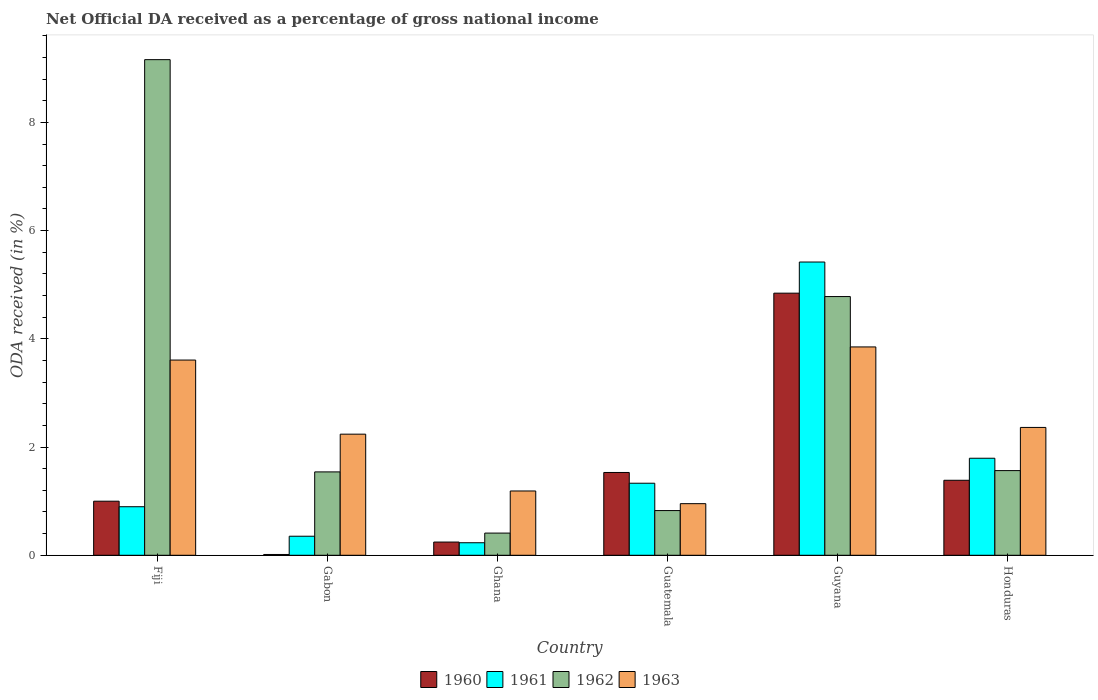How many different coloured bars are there?
Make the answer very short. 4. Are the number of bars per tick equal to the number of legend labels?
Keep it short and to the point. Yes. Are the number of bars on each tick of the X-axis equal?
Provide a short and direct response. Yes. How many bars are there on the 4th tick from the left?
Provide a short and direct response. 4. What is the label of the 4th group of bars from the left?
Ensure brevity in your answer.  Guatemala. What is the net official DA received in 1962 in Guyana?
Offer a very short reply. 4.78. Across all countries, what is the maximum net official DA received in 1960?
Your response must be concise. 4.84. Across all countries, what is the minimum net official DA received in 1963?
Provide a short and direct response. 0.95. In which country was the net official DA received in 1963 maximum?
Your response must be concise. Guyana. In which country was the net official DA received in 1962 minimum?
Offer a very short reply. Ghana. What is the total net official DA received in 1963 in the graph?
Your answer should be compact. 14.2. What is the difference between the net official DA received in 1963 in Fiji and that in Guyana?
Your answer should be compact. -0.24. What is the difference between the net official DA received in 1961 in Guyana and the net official DA received in 1962 in Ghana?
Offer a very short reply. 5.01. What is the average net official DA received in 1961 per country?
Give a very brief answer. 1.67. What is the difference between the net official DA received of/in 1962 and net official DA received of/in 1963 in Guatemala?
Give a very brief answer. -0.13. What is the ratio of the net official DA received in 1961 in Gabon to that in Guatemala?
Offer a terse response. 0.26. What is the difference between the highest and the second highest net official DA received in 1961?
Your answer should be compact. -3.63. What is the difference between the highest and the lowest net official DA received in 1963?
Keep it short and to the point. 2.9. Is it the case that in every country, the sum of the net official DA received in 1962 and net official DA received in 1961 is greater than the sum of net official DA received in 1963 and net official DA received in 1960?
Ensure brevity in your answer.  No. Is it the case that in every country, the sum of the net official DA received in 1962 and net official DA received in 1961 is greater than the net official DA received in 1960?
Keep it short and to the point. Yes. How many bars are there?
Your answer should be very brief. 24. Are all the bars in the graph horizontal?
Provide a short and direct response. No. How many countries are there in the graph?
Your answer should be very brief. 6. Does the graph contain any zero values?
Provide a succinct answer. No. Does the graph contain grids?
Give a very brief answer. No. How many legend labels are there?
Provide a succinct answer. 4. What is the title of the graph?
Your response must be concise. Net Official DA received as a percentage of gross national income. Does "2013" appear as one of the legend labels in the graph?
Your answer should be very brief. No. What is the label or title of the X-axis?
Keep it short and to the point. Country. What is the label or title of the Y-axis?
Give a very brief answer. ODA received (in %). What is the ODA received (in %) of 1960 in Fiji?
Your answer should be very brief. 1. What is the ODA received (in %) in 1961 in Fiji?
Offer a terse response. 0.9. What is the ODA received (in %) of 1962 in Fiji?
Make the answer very short. 9.16. What is the ODA received (in %) in 1963 in Fiji?
Ensure brevity in your answer.  3.61. What is the ODA received (in %) in 1960 in Gabon?
Provide a short and direct response. 0.01. What is the ODA received (in %) of 1961 in Gabon?
Your answer should be very brief. 0.35. What is the ODA received (in %) of 1962 in Gabon?
Your answer should be very brief. 1.54. What is the ODA received (in %) in 1963 in Gabon?
Give a very brief answer. 2.24. What is the ODA received (in %) of 1960 in Ghana?
Your response must be concise. 0.24. What is the ODA received (in %) of 1961 in Ghana?
Your response must be concise. 0.23. What is the ODA received (in %) of 1962 in Ghana?
Provide a short and direct response. 0.41. What is the ODA received (in %) of 1963 in Ghana?
Offer a terse response. 1.19. What is the ODA received (in %) in 1960 in Guatemala?
Ensure brevity in your answer.  1.53. What is the ODA received (in %) in 1961 in Guatemala?
Make the answer very short. 1.33. What is the ODA received (in %) of 1962 in Guatemala?
Offer a terse response. 0.83. What is the ODA received (in %) in 1963 in Guatemala?
Give a very brief answer. 0.95. What is the ODA received (in %) of 1960 in Guyana?
Offer a terse response. 4.84. What is the ODA received (in %) in 1961 in Guyana?
Your answer should be very brief. 5.42. What is the ODA received (in %) in 1962 in Guyana?
Make the answer very short. 4.78. What is the ODA received (in %) in 1963 in Guyana?
Make the answer very short. 3.85. What is the ODA received (in %) of 1960 in Honduras?
Your answer should be compact. 1.39. What is the ODA received (in %) of 1961 in Honduras?
Your answer should be very brief. 1.79. What is the ODA received (in %) in 1962 in Honduras?
Keep it short and to the point. 1.56. What is the ODA received (in %) of 1963 in Honduras?
Offer a terse response. 2.36. Across all countries, what is the maximum ODA received (in %) of 1960?
Provide a succinct answer. 4.84. Across all countries, what is the maximum ODA received (in %) in 1961?
Give a very brief answer. 5.42. Across all countries, what is the maximum ODA received (in %) in 1962?
Offer a very short reply. 9.16. Across all countries, what is the maximum ODA received (in %) in 1963?
Provide a succinct answer. 3.85. Across all countries, what is the minimum ODA received (in %) in 1960?
Give a very brief answer. 0.01. Across all countries, what is the minimum ODA received (in %) in 1961?
Provide a succinct answer. 0.23. Across all countries, what is the minimum ODA received (in %) in 1962?
Keep it short and to the point. 0.41. Across all countries, what is the minimum ODA received (in %) in 1963?
Keep it short and to the point. 0.95. What is the total ODA received (in %) in 1960 in the graph?
Provide a succinct answer. 9.02. What is the total ODA received (in %) in 1961 in the graph?
Ensure brevity in your answer.  10.03. What is the total ODA received (in %) in 1962 in the graph?
Make the answer very short. 18.28. What is the total ODA received (in %) in 1963 in the graph?
Keep it short and to the point. 14.2. What is the difference between the ODA received (in %) of 1960 in Fiji and that in Gabon?
Your answer should be very brief. 0.98. What is the difference between the ODA received (in %) of 1961 in Fiji and that in Gabon?
Provide a succinct answer. 0.55. What is the difference between the ODA received (in %) of 1962 in Fiji and that in Gabon?
Your answer should be very brief. 7.62. What is the difference between the ODA received (in %) of 1963 in Fiji and that in Gabon?
Make the answer very short. 1.37. What is the difference between the ODA received (in %) in 1960 in Fiji and that in Ghana?
Keep it short and to the point. 0.76. What is the difference between the ODA received (in %) in 1961 in Fiji and that in Ghana?
Make the answer very short. 0.67. What is the difference between the ODA received (in %) of 1962 in Fiji and that in Ghana?
Give a very brief answer. 8.75. What is the difference between the ODA received (in %) in 1963 in Fiji and that in Ghana?
Your answer should be compact. 2.42. What is the difference between the ODA received (in %) in 1960 in Fiji and that in Guatemala?
Ensure brevity in your answer.  -0.53. What is the difference between the ODA received (in %) in 1961 in Fiji and that in Guatemala?
Give a very brief answer. -0.43. What is the difference between the ODA received (in %) in 1962 in Fiji and that in Guatemala?
Your answer should be compact. 8.33. What is the difference between the ODA received (in %) in 1963 in Fiji and that in Guatemala?
Provide a short and direct response. 2.65. What is the difference between the ODA received (in %) of 1960 in Fiji and that in Guyana?
Your answer should be compact. -3.84. What is the difference between the ODA received (in %) in 1961 in Fiji and that in Guyana?
Make the answer very short. -4.52. What is the difference between the ODA received (in %) of 1962 in Fiji and that in Guyana?
Ensure brevity in your answer.  4.38. What is the difference between the ODA received (in %) of 1963 in Fiji and that in Guyana?
Offer a terse response. -0.24. What is the difference between the ODA received (in %) in 1960 in Fiji and that in Honduras?
Your response must be concise. -0.39. What is the difference between the ODA received (in %) of 1961 in Fiji and that in Honduras?
Keep it short and to the point. -0.9. What is the difference between the ODA received (in %) of 1962 in Fiji and that in Honduras?
Ensure brevity in your answer.  7.59. What is the difference between the ODA received (in %) of 1963 in Fiji and that in Honduras?
Ensure brevity in your answer.  1.25. What is the difference between the ODA received (in %) of 1960 in Gabon and that in Ghana?
Keep it short and to the point. -0.23. What is the difference between the ODA received (in %) of 1961 in Gabon and that in Ghana?
Provide a succinct answer. 0.12. What is the difference between the ODA received (in %) in 1962 in Gabon and that in Ghana?
Make the answer very short. 1.13. What is the difference between the ODA received (in %) in 1963 in Gabon and that in Ghana?
Make the answer very short. 1.05. What is the difference between the ODA received (in %) in 1960 in Gabon and that in Guatemala?
Offer a very short reply. -1.52. What is the difference between the ODA received (in %) of 1961 in Gabon and that in Guatemala?
Offer a terse response. -0.98. What is the difference between the ODA received (in %) of 1962 in Gabon and that in Guatemala?
Your answer should be compact. 0.71. What is the difference between the ODA received (in %) of 1963 in Gabon and that in Guatemala?
Your response must be concise. 1.28. What is the difference between the ODA received (in %) of 1960 in Gabon and that in Guyana?
Your response must be concise. -4.83. What is the difference between the ODA received (in %) in 1961 in Gabon and that in Guyana?
Make the answer very short. -5.07. What is the difference between the ODA received (in %) in 1962 in Gabon and that in Guyana?
Offer a very short reply. -3.24. What is the difference between the ODA received (in %) of 1963 in Gabon and that in Guyana?
Provide a succinct answer. -1.61. What is the difference between the ODA received (in %) of 1960 in Gabon and that in Honduras?
Offer a very short reply. -1.37. What is the difference between the ODA received (in %) in 1961 in Gabon and that in Honduras?
Your answer should be compact. -1.44. What is the difference between the ODA received (in %) in 1962 in Gabon and that in Honduras?
Offer a very short reply. -0.02. What is the difference between the ODA received (in %) in 1963 in Gabon and that in Honduras?
Keep it short and to the point. -0.12. What is the difference between the ODA received (in %) of 1960 in Ghana and that in Guatemala?
Offer a terse response. -1.29. What is the difference between the ODA received (in %) in 1961 in Ghana and that in Guatemala?
Your answer should be very brief. -1.1. What is the difference between the ODA received (in %) in 1962 in Ghana and that in Guatemala?
Keep it short and to the point. -0.42. What is the difference between the ODA received (in %) of 1963 in Ghana and that in Guatemala?
Make the answer very short. 0.23. What is the difference between the ODA received (in %) of 1960 in Ghana and that in Guyana?
Your response must be concise. -4.6. What is the difference between the ODA received (in %) in 1961 in Ghana and that in Guyana?
Offer a very short reply. -5.19. What is the difference between the ODA received (in %) in 1962 in Ghana and that in Guyana?
Provide a succinct answer. -4.37. What is the difference between the ODA received (in %) in 1963 in Ghana and that in Guyana?
Your answer should be compact. -2.66. What is the difference between the ODA received (in %) in 1960 in Ghana and that in Honduras?
Offer a very short reply. -1.14. What is the difference between the ODA received (in %) of 1961 in Ghana and that in Honduras?
Give a very brief answer. -1.56. What is the difference between the ODA received (in %) of 1962 in Ghana and that in Honduras?
Offer a very short reply. -1.15. What is the difference between the ODA received (in %) in 1963 in Ghana and that in Honduras?
Provide a succinct answer. -1.17. What is the difference between the ODA received (in %) in 1960 in Guatemala and that in Guyana?
Provide a short and direct response. -3.31. What is the difference between the ODA received (in %) in 1961 in Guatemala and that in Guyana?
Keep it short and to the point. -4.09. What is the difference between the ODA received (in %) of 1962 in Guatemala and that in Guyana?
Offer a terse response. -3.96. What is the difference between the ODA received (in %) in 1963 in Guatemala and that in Guyana?
Make the answer very short. -2.9. What is the difference between the ODA received (in %) of 1960 in Guatemala and that in Honduras?
Your answer should be very brief. 0.14. What is the difference between the ODA received (in %) of 1961 in Guatemala and that in Honduras?
Provide a short and direct response. -0.46. What is the difference between the ODA received (in %) in 1962 in Guatemala and that in Honduras?
Offer a terse response. -0.74. What is the difference between the ODA received (in %) of 1963 in Guatemala and that in Honduras?
Your answer should be compact. -1.41. What is the difference between the ODA received (in %) of 1960 in Guyana and that in Honduras?
Ensure brevity in your answer.  3.46. What is the difference between the ODA received (in %) in 1961 in Guyana and that in Honduras?
Offer a very short reply. 3.63. What is the difference between the ODA received (in %) of 1962 in Guyana and that in Honduras?
Make the answer very short. 3.22. What is the difference between the ODA received (in %) in 1963 in Guyana and that in Honduras?
Provide a short and direct response. 1.49. What is the difference between the ODA received (in %) in 1960 in Fiji and the ODA received (in %) in 1961 in Gabon?
Provide a short and direct response. 0.65. What is the difference between the ODA received (in %) of 1960 in Fiji and the ODA received (in %) of 1962 in Gabon?
Ensure brevity in your answer.  -0.54. What is the difference between the ODA received (in %) in 1960 in Fiji and the ODA received (in %) in 1963 in Gabon?
Your answer should be compact. -1.24. What is the difference between the ODA received (in %) in 1961 in Fiji and the ODA received (in %) in 1962 in Gabon?
Provide a succinct answer. -0.64. What is the difference between the ODA received (in %) of 1961 in Fiji and the ODA received (in %) of 1963 in Gabon?
Ensure brevity in your answer.  -1.34. What is the difference between the ODA received (in %) in 1962 in Fiji and the ODA received (in %) in 1963 in Gabon?
Offer a very short reply. 6.92. What is the difference between the ODA received (in %) in 1960 in Fiji and the ODA received (in %) in 1961 in Ghana?
Provide a short and direct response. 0.77. What is the difference between the ODA received (in %) in 1960 in Fiji and the ODA received (in %) in 1962 in Ghana?
Your answer should be compact. 0.59. What is the difference between the ODA received (in %) of 1960 in Fiji and the ODA received (in %) of 1963 in Ghana?
Keep it short and to the point. -0.19. What is the difference between the ODA received (in %) of 1961 in Fiji and the ODA received (in %) of 1962 in Ghana?
Make the answer very short. 0.49. What is the difference between the ODA received (in %) of 1961 in Fiji and the ODA received (in %) of 1963 in Ghana?
Give a very brief answer. -0.29. What is the difference between the ODA received (in %) in 1962 in Fiji and the ODA received (in %) in 1963 in Ghana?
Your response must be concise. 7.97. What is the difference between the ODA received (in %) in 1960 in Fiji and the ODA received (in %) in 1961 in Guatemala?
Your answer should be very brief. -0.33. What is the difference between the ODA received (in %) in 1960 in Fiji and the ODA received (in %) in 1962 in Guatemala?
Your answer should be compact. 0.17. What is the difference between the ODA received (in %) in 1960 in Fiji and the ODA received (in %) in 1963 in Guatemala?
Keep it short and to the point. 0.05. What is the difference between the ODA received (in %) in 1961 in Fiji and the ODA received (in %) in 1962 in Guatemala?
Provide a short and direct response. 0.07. What is the difference between the ODA received (in %) of 1961 in Fiji and the ODA received (in %) of 1963 in Guatemala?
Offer a very short reply. -0.06. What is the difference between the ODA received (in %) of 1962 in Fiji and the ODA received (in %) of 1963 in Guatemala?
Your answer should be very brief. 8.21. What is the difference between the ODA received (in %) in 1960 in Fiji and the ODA received (in %) in 1961 in Guyana?
Offer a very short reply. -4.42. What is the difference between the ODA received (in %) of 1960 in Fiji and the ODA received (in %) of 1962 in Guyana?
Make the answer very short. -3.78. What is the difference between the ODA received (in %) of 1960 in Fiji and the ODA received (in %) of 1963 in Guyana?
Your answer should be compact. -2.85. What is the difference between the ODA received (in %) in 1961 in Fiji and the ODA received (in %) in 1962 in Guyana?
Make the answer very short. -3.88. What is the difference between the ODA received (in %) in 1961 in Fiji and the ODA received (in %) in 1963 in Guyana?
Offer a very short reply. -2.95. What is the difference between the ODA received (in %) of 1962 in Fiji and the ODA received (in %) of 1963 in Guyana?
Your answer should be very brief. 5.31. What is the difference between the ODA received (in %) of 1960 in Fiji and the ODA received (in %) of 1961 in Honduras?
Keep it short and to the point. -0.79. What is the difference between the ODA received (in %) in 1960 in Fiji and the ODA received (in %) in 1962 in Honduras?
Keep it short and to the point. -0.57. What is the difference between the ODA received (in %) in 1960 in Fiji and the ODA received (in %) in 1963 in Honduras?
Make the answer very short. -1.36. What is the difference between the ODA received (in %) of 1961 in Fiji and the ODA received (in %) of 1962 in Honduras?
Offer a very short reply. -0.67. What is the difference between the ODA received (in %) in 1961 in Fiji and the ODA received (in %) in 1963 in Honduras?
Your response must be concise. -1.47. What is the difference between the ODA received (in %) of 1962 in Fiji and the ODA received (in %) of 1963 in Honduras?
Keep it short and to the point. 6.8. What is the difference between the ODA received (in %) in 1960 in Gabon and the ODA received (in %) in 1961 in Ghana?
Your answer should be compact. -0.22. What is the difference between the ODA received (in %) in 1960 in Gabon and the ODA received (in %) in 1962 in Ghana?
Your response must be concise. -0.4. What is the difference between the ODA received (in %) in 1960 in Gabon and the ODA received (in %) in 1963 in Ghana?
Your answer should be compact. -1.17. What is the difference between the ODA received (in %) of 1961 in Gabon and the ODA received (in %) of 1962 in Ghana?
Keep it short and to the point. -0.06. What is the difference between the ODA received (in %) in 1961 in Gabon and the ODA received (in %) in 1963 in Ghana?
Make the answer very short. -0.84. What is the difference between the ODA received (in %) of 1962 in Gabon and the ODA received (in %) of 1963 in Ghana?
Keep it short and to the point. 0.35. What is the difference between the ODA received (in %) of 1960 in Gabon and the ODA received (in %) of 1961 in Guatemala?
Provide a succinct answer. -1.32. What is the difference between the ODA received (in %) of 1960 in Gabon and the ODA received (in %) of 1962 in Guatemala?
Keep it short and to the point. -0.81. What is the difference between the ODA received (in %) in 1960 in Gabon and the ODA received (in %) in 1963 in Guatemala?
Offer a very short reply. -0.94. What is the difference between the ODA received (in %) of 1961 in Gabon and the ODA received (in %) of 1962 in Guatemala?
Give a very brief answer. -0.47. What is the difference between the ODA received (in %) of 1961 in Gabon and the ODA received (in %) of 1963 in Guatemala?
Your response must be concise. -0.6. What is the difference between the ODA received (in %) of 1962 in Gabon and the ODA received (in %) of 1963 in Guatemala?
Your answer should be very brief. 0.59. What is the difference between the ODA received (in %) in 1960 in Gabon and the ODA received (in %) in 1961 in Guyana?
Provide a succinct answer. -5.4. What is the difference between the ODA received (in %) in 1960 in Gabon and the ODA received (in %) in 1962 in Guyana?
Offer a very short reply. -4.77. What is the difference between the ODA received (in %) of 1960 in Gabon and the ODA received (in %) of 1963 in Guyana?
Keep it short and to the point. -3.84. What is the difference between the ODA received (in %) of 1961 in Gabon and the ODA received (in %) of 1962 in Guyana?
Provide a succinct answer. -4.43. What is the difference between the ODA received (in %) in 1961 in Gabon and the ODA received (in %) in 1963 in Guyana?
Keep it short and to the point. -3.5. What is the difference between the ODA received (in %) in 1962 in Gabon and the ODA received (in %) in 1963 in Guyana?
Keep it short and to the point. -2.31. What is the difference between the ODA received (in %) of 1960 in Gabon and the ODA received (in %) of 1961 in Honduras?
Offer a very short reply. -1.78. What is the difference between the ODA received (in %) in 1960 in Gabon and the ODA received (in %) in 1962 in Honduras?
Ensure brevity in your answer.  -1.55. What is the difference between the ODA received (in %) in 1960 in Gabon and the ODA received (in %) in 1963 in Honduras?
Give a very brief answer. -2.35. What is the difference between the ODA received (in %) in 1961 in Gabon and the ODA received (in %) in 1962 in Honduras?
Your answer should be very brief. -1.21. What is the difference between the ODA received (in %) of 1961 in Gabon and the ODA received (in %) of 1963 in Honduras?
Your answer should be compact. -2.01. What is the difference between the ODA received (in %) in 1962 in Gabon and the ODA received (in %) in 1963 in Honduras?
Provide a short and direct response. -0.82. What is the difference between the ODA received (in %) of 1960 in Ghana and the ODA received (in %) of 1961 in Guatemala?
Keep it short and to the point. -1.09. What is the difference between the ODA received (in %) of 1960 in Ghana and the ODA received (in %) of 1962 in Guatemala?
Offer a very short reply. -0.58. What is the difference between the ODA received (in %) of 1960 in Ghana and the ODA received (in %) of 1963 in Guatemala?
Provide a short and direct response. -0.71. What is the difference between the ODA received (in %) of 1961 in Ghana and the ODA received (in %) of 1962 in Guatemala?
Your answer should be very brief. -0.59. What is the difference between the ODA received (in %) in 1961 in Ghana and the ODA received (in %) in 1963 in Guatemala?
Make the answer very short. -0.72. What is the difference between the ODA received (in %) of 1962 in Ghana and the ODA received (in %) of 1963 in Guatemala?
Provide a short and direct response. -0.54. What is the difference between the ODA received (in %) in 1960 in Ghana and the ODA received (in %) in 1961 in Guyana?
Provide a short and direct response. -5.18. What is the difference between the ODA received (in %) in 1960 in Ghana and the ODA received (in %) in 1962 in Guyana?
Your response must be concise. -4.54. What is the difference between the ODA received (in %) of 1960 in Ghana and the ODA received (in %) of 1963 in Guyana?
Provide a short and direct response. -3.61. What is the difference between the ODA received (in %) of 1961 in Ghana and the ODA received (in %) of 1962 in Guyana?
Your answer should be compact. -4.55. What is the difference between the ODA received (in %) in 1961 in Ghana and the ODA received (in %) in 1963 in Guyana?
Offer a terse response. -3.62. What is the difference between the ODA received (in %) in 1962 in Ghana and the ODA received (in %) in 1963 in Guyana?
Offer a terse response. -3.44. What is the difference between the ODA received (in %) in 1960 in Ghana and the ODA received (in %) in 1961 in Honduras?
Make the answer very short. -1.55. What is the difference between the ODA received (in %) in 1960 in Ghana and the ODA received (in %) in 1962 in Honduras?
Keep it short and to the point. -1.32. What is the difference between the ODA received (in %) of 1960 in Ghana and the ODA received (in %) of 1963 in Honduras?
Give a very brief answer. -2.12. What is the difference between the ODA received (in %) in 1961 in Ghana and the ODA received (in %) in 1962 in Honduras?
Your answer should be very brief. -1.33. What is the difference between the ODA received (in %) in 1961 in Ghana and the ODA received (in %) in 1963 in Honduras?
Your answer should be compact. -2.13. What is the difference between the ODA received (in %) of 1962 in Ghana and the ODA received (in %) of 1963 in Honduras?
Keep it short and to the point. -1.95. What is the difference between the ODA received (in %) in 1960 in Guatemala and the ODA received (in %) in 1961 in Guyana?
Provide a succinct answer. -3.89. What is the difference between the ODA received (in %) of 1960 in Guatemala and the ODA received (in %) of 1962 in Guyana?
Your answer should be compact. -3.25. What is the difference between the ODA received (in %) of 1960 in Guatemala and the ODA received (in %) of 1963 in Guyana?
Offer a terse response. -2.32. What is the difference between the ODA received (in %) in 1961 in Guatemala and the ODA received (in %) in 1962 in Guyana?
Ensure brevity in your answer.  -3.45. What is the difference between the ODA received (in %) in 1961 in Guatemala and the ODA received (in %) in 1963 in Guyana?
Your answer should be very brief. -2.52. What is the difference between the ODA received (in %) in 1962 in Guatemala and the ODA received (in %) in 1963 in Guyana?
Provide a succinct answer. -3.02. What is the difference between the ODA received (in %) of 1960 in Guatemala and the ODA received (in %) of 1961 in Honduras?
Ensure brevity in your answer.  -0.26. What is the difference between the ODA received (in %) in 1960 in Guatemala and the ODA received (in %) in 1962 in Honduras?
Ensure brevity in your answer.  -0.03. What is the difference between the ODA received (in %) in 1960 in Guatemala and the ODA received (in %) in 1963 in Honduras?
Give a very brief answer. -0.83. What is the difference between the ODA received (in %) of 1961 in Guatemala and the ODA received (in %) of 1962 in Honduras?
Your answer should be very brief. -0.23. What is the difference between the ODA received (in %) in 1961 in Guatemala and the ODA received (in %) in 1963 in Honduras?
Offer a very short reply. -1.03. What is the difference between the ODA received (in %) in 1962 in Guatemala and the ODA received (in %) in 1963 in Honduras?
Provide a short and direct response. -1.54. What is the difference between the ODA received (in %) of 1960 in Guyana and the ODA received (in %) of 1961 in Honduras?
Make the answer very short. 3.05. What is the difference between the ODA received (in %) of 1960 in Guyana and the ODA received (in %) of 1962 in Honduras?
Provide a succinct answer. 3.28. What is the difference between the ODA received (in %) of 1960 in Guyana and the ODA received (in %) of 1963 in Honduras?
Offer a very short reply. 2.48. What is the difference between the ODA received (in %) of 1961 in Guyana and the ODA received (in %) of 1962 in Honduras?
Provide a succinct answer. 3.85. What is the difference between the ODA received (in %) of 1961 in Guyana and the ODA received (in %) of 1963 in Honduras?
Offer a very short reply. 3.06. What is the difference between the ODA received (in %) in 1962 in Guyana and the ODA received (in %) in 1963 in Honduras?
Keep it short and to the point. 2.42. What is the average ODA received (in %) in 1960 per country?
Keep it short and to the point. 1.5. What is the average ODA received (in %) in 1961 per country?
Offer a very short reply. 1.67. What is the average ODA received (in %) of 1962 per country?
Make the answer very short. 3.05. What is the average ODA received (in %) in 1963 per country?
Your answer should be compact. 2.37. What is the difference between the ODA received (in %) of 1960 and ODA received (in %) of 1961 in Fiji?
Your answer should be compact. 0.1. What is the difference between the ODA received (in %) of 1960 and ODA received (in %) of 1962 in Fiji?
Make the answer very short. -8.16. What is the difference between the ODA received (in %) of 1960 and ODA received (in %) of 1963 in Fiji?
Provide a short and direct response. -2.61. What is the difference between the ODA received (in %) in 1961 and ODA received (in %) in 1962 in Fiji?
Your answer should be compact. -8.26. What is the difference between the ODA received (in %) of 1961 and ODA received (in %) of 1963 in Fiji?
Make the answer very short. -2.71. What is the difference between the ODA received (in %) in 1962 and ODA received (in %) in 1963 in Fiji?
Your answer should be compact. 5.55. What is the difference between the ODA received (in %) of 1960 and ODA received (in %) of 1961 in Gabon?
Your response must be concise. -0.34. What is the difference between the ODA received (in %) of 1960 and ODA received (in %) of 1962 in Gabon?
Make the answer very short. -1.53. What is the difference between the ODA received (in %) of 1960 and ODA received (in %) of 1963 in Gabon?
Make the answer very short. -2.22. What is the difference between the ODA received (in %) in 1961 and ODA received (in %) in 1962 in Gabon?
Your response must be concise. -1.19. What is the difference between the ODA received (in %) of 1961 and ODA received (in %) of 1963 in Gabon?
Your answer should be very brief. -1.89. What is the difference between the ODA received (in %) of 1962 and ODA received (in %) of 1963 in Gabon?
Provide a short and direct response. -0.7. What is the difference between the ODA received (in %) in 1960 and ODA received (in %) in 1961 in Ghana?
Ensure brevity in your answer.  0.01. What is the difference between the ODA received (in %) of 1960 and ODA received (in %) of 1962 in Ghana?
Your response must be concise. -0.17. What is the difference between the ODA received (in %) of 1960 and ODA received (in %) of 1963 in Ghana?
Give a very brief answer. -0.94. What is the difference between the ODA received (in %) in 1961 and ODA received (in %) in 1962 in Ghana?
Give a very brief answer. -0.18. What is the difference between the ODA received (in %) of 1961 and ODA received (in %) of 1963 in Ghana?
Provide a short and direct response. -0.96. What is the difference between the ODA received (in %) in 1962 and ODA received (in %) in 1963 in Ghana?
Keep it short and to the point. -0.78. What is the difference between the ODA received (in %) of 1960 and ODA received (in %) of 1961 in Guatemala?
Keep it short and to the point. 0.2. What is the difference between the ODA received (in %) in 1960 and ODA received (in %) in 1962 in Guatemala?
Offer a very short reply. 0.7. What is the difference between the ODA received (in %) in 1960 and ODA received (in %) in 1963 in Guatemala?
Make the answer very short. 0.58. What is the difference between the ODA received (in %) of 1961 and ODA received (in %) of 1962 in Guatemala?
Ensure brevity in your answer.  0.51. What is the difference between the ODA received (in %) of 1961 and ODA received (in %) of 1963 in Guatemala?
Provide a short and direct response. 0.38. What is the difference between the ODA received (in %) of 1962 and ODA received (in %) of 1963 in Guatemala?
Provide a short and direct response. -0.13. What is the difference between the ODA received (in %) in 1960 and ODA received (in %) in 1961 in Guyana?
Your answer should be compact. -0.58. What is the difference between the ODA received (in %) in 1960 and ODA received (in %) in 1962 in Guyana?
Offer a terse response. 0.06. What is the difference between the ODA received (in %) of 1960 and ODA received (in %) of 1963 in Guyana?
Ensure brevity in your answer.  0.99. What is the difference between the ODA received (in %) in 1961 and ODA received (in %) in 1962 in Guyana?
Your answer should be compact. 0.64. What is the difference between the ODA received (in %) in 1961 and ODA received (in %) in 1963 in Guyana?
Provide a short and direct response. 1.57. What is the difference between the ODA received (in %) in 1962 and ODA received (in %) in 1963 in Guyana?
Keep it short and to the point. 0.93. What is the difference between the ODA received (in %) in 1960 and ODA received (in %) in 1961 in Honduras?
Offer a terse response. -0.41. What is the difference between the ODA received (in %) in 1960 and ODA received (in %) in 1962 in Honduras?
Ensure brevity in your answer.  -0.18. What is the difference between the ODA received (in %) of 1960 and ODA received (in %) of 1963 in Honduras?
Your answer should be very brief. -0.98. What is the difference between the ODA received (in %) of 1961 and ODA received (in %) of 1962 in Honduras?
Offer a very short reply. 0.23. What is the difference between the ODA received (in %) of 1961 and ODA received (in %) of 1963 in Honduras?
Provide a succinct answer. -0.57. What is the difference between the ODA received (in %) of 1962 and ODA received (in %) of 1963 in Honduras?
Offer a very short reply. -0.8. What is the ratio of the ODA received (in %) of 1960 in Fiji to that in Gabon?
Your response must be concise. 67.36. What is the ratio of the ODA received (in %) in 1961 in Fiji to that in Gabon?
Make the answer very short. 2.55. What is the ratio of the ODA received (in %) in 1962 in Fiji to that in Gabon?
Your response must be concise. 5.94. What is the ratio of the ODA received (in %) of 1963 in Fiji to that in Gabon?
Offer a very short reply. 1.61. What is the ratio of the ODA received (in %) in 1960 in Fiji to that in Ghana?
Keep it short and to the point. 4.09. What is the ratio of the ODA received (in %) of 1961 in Fiji to that in Ghana?
Your response must be concise. 3.88. What is the ratio of the ODA received (in %) in 1962 in Fiji to that in Ghana?
Your answer should be compact. 22.34. What is the ratio of the ODA received (in %) of 1963 in Fiji to that in Ghana?
Provide a succinct answer. 3.04. What is the ratio of the ODA received (in %) in 1960 in Fiji to that in Guatemala?
Ensure brevity in your answer.  0.65. What is the ratio of the ODA received (in %) in 1961 in Fiji to that in Guatemala?
Provide a succinct answer. 0.67. What is the ratio of the ODA received (in %) in 1962 in Fiji to that in Guatemala?
Ensure brevity in your answer.  11.09. What is the ratio of the ODA received (in %) of 1963 in Fiji to that in Guatemala?
Keep it short and to the point. 3.78. What is the ratio of the ODA received (in %) in 1960 in Fiji to that in Guyana?
Offer a very short reply. 0.21. What is the ratio of the ODA received (in %) in 1961 in Fiji to that in Guyana?
Ensure brevity in your answer.  0.17. What is the ratio of the ODA received (in %) of 1962 in Fiji to that in Guyana?
Keep it short and to the point. 1.92. What is the ratio of the ODA received (in %) of 1963 in Fiji to that in Guyana?
Provide a succinct answer. 0.94. What is the ratio of the ODA received (in %) of 1960 in Fiji to that in Honduras?
Provide a succinct answer. 0.72. What is the ratio of the ODA received (in %) of 1961 in Fiji to that in Honduras?
Provide a short and direct response. 0.5. What is the ratio of the ODA received (in %) of 1962 in Fiji to that in Honduras?
Offer a terse response. 5.85. What is the ratio of the ODA received (in %) of 1963 in Fiji to that in Honduras?
Your response must be concise. 1.53. What is the ratio of the ODA received (in %) of 1960 in Gabon to that in Ghana?
Keep it short and to the point. 0.06. What is the ratio of the ODA received (in %) in 1961 in Gabon to that in Ghana?
Provide a succinct answer. 1.52. What is the ratio of the ODA received (in %) of 1962 in Gabon to that in Ghana?
Provide a short and direct response. 3.76. What is the ratio of the ODA received (in %) of 1963 in Gabon to that in Ghana?
Ensure brevity in your answer.  1.88. What is the ratio of the ODA received (in %) in 1960 in Gabon to that in Guatemala?
Offer a very short reply. 0.01. What is the ratio of the ODA received (in %) in 1961 in Gabon to that in Guatemala?
Your response must be concise. 0.26. What is the ratio of the ODA received (in %) in 1962 in Gabon to that in Guatemala?
Keep it short and to the point. 1.86. What is the ratio of the ODA received (in %) of 1963 in Gabon to that in Guatemala?
Make the answer very short. 2.35. What is the ratio of the ODA received (in %) of 1960 in Gabon to that in Guyana?
Offer a terse response. 0. What is the ratio of the ODA received (in %) in 1961 in Gabon to that in Guyana?
Ensure brevity in your answer.  0.07. What is the ratio of the ODA received (in %) in 1962 in Gabon to that in Guyana?
Offer a very short reply. 0.32. What is the ratio of the ODA received (in %) of 1963 in Gabon to that in Guyana?
Your answer should be very brief. 0.58. What is the ratio of the ODA received (in %) of 1960 in Gabon to that in Honduras?
Your response must be concise. 0.01. What is the ratio of the ODA received (in %) in 1961 in Gabon to that in Honduras?
Ensure brevity in your answer.  0.2. What is the ratio of the ODA received (in %) of 1962 in Gabon to that in Honduras?
Provide a succinct answer. 0.98. What is the ratio of the ODA received (in %) in 1963 in Gabon to that in Honduras?
Your answer should be very brief. 0.95. What is the ratio of the ODA received (in %) of 1960 in Ghana to that in Guatemala?
Provide a succinct answer. 0.16. What is the ratio of the ODA received (in %) of 1961 in Ghana to that in Guatemala?
Offer a terse response. 0.17. What is the ratio of the ODA received (in %) of 1962 in Ghana to that in Guatemala?
Give a very brief answer. 0.5. What is the ratio of the ODA received (in %) of 1963 in Ghana to that in Guatemala?
Provide a succinct answer. 1.25. What is the ratio of the ODA received (in %) of 1960 in Ghana to that in Guyana?
Your answer should be very brief. 0.05. What is the ratio of the ODA received (in %) in 1961 in Ghana to that in Guyana?
Offer a very short reply. 0.04. What is the ratio of the ODA received (in %) of 1962 in Ghana to that in Guyana?
Offer a terse response. 0.09. What is the ratio of the ODA received (in %) in 1963 in Ghana to that in Guyana?
Provide a succinct answer. 0.31. What is the ratio of the ODA received (in %) of 1960 in Ghana to that in Honduras?
Offer a terse response. 0.18. What is the ratio of the ODA received (in %) of 1961 in Ghana to that in Honduras?
Provide a short and direct response. 0.13. What is the ratio of the ODA received (in %) of 1962 in Ghana to that in Honduras?
Ensure brevity in your answer.  0.26. What is the ratio of the ODA received (in %) in 1963 in Ghana to that in Honduras?
Offer a very short reply. 0.5. What is the ratio of the ODA received (in %) of 1960 in Guatemala to that in Guyana?
Your answer should be very brief. 0.32. What is the ratio of the ODA received (in %) of 1961 in Guatemala to that in Guyana?
Offer a terse response. 0.25. What is the ratio of the ODA received (in %) in 1962 in Guatemala to that in Guyana?
Provide a succinct answer. 0.17. What is the ratio of the ODA received (in %) in 1963 in Guatemala to that in Guyana?
Give a very brief answer. 0.25. What is the ratio of the ODA received (in %) in 1960 in Guatemala to that in Honduras?
Your answer should be compact. 1.1. What is the ratio of the ODA received (in %) of 1961 in Guatemala to that in Honduras?
Provide a short and direct response. 0.74. What is the ratio of the ODA received (in %) in 1962 in Guatemala to that in Honduras?
Your answer should be compact. 0.53. What is the ratio of the ODA received (in %) of 1963 in Guatemala to that in Honduras?
Ensure brevity in your answer.  0.4. What is the ratio of the ODA received (in %) in 1960 in Guyana to that in Honduras?
Offer a very short reply. 3.49. What is the ratio of the ODA received (in %) in 1961 in Guyana to that in Honduras?
Ensure brevity in your answer.  3.02. What is the ratio of the ODA received (in %) in 1962 in Guyana to that in Honduras?
Provide a short and direct response. 3.06. What is the ratio of the ODA received (in %) of 1963 in Guyana to that in Honduras?
Give a very brief answer. 1.63. What is the difference between the highest and the second highest ODA received (in %) of 1960?
Offer a terse response. 3.31. What is the difference between the highest and the second highest ODA received (in %) in 1961?
Your response must be concise. 3.63. What is the difference between the highest and the second highest ODA received (in %) in 1962?
Give a very brief answer. 4.38. What is the difference between the highest and the second highest ODA received (in %) of 1963?
Make the answer very short. 0.24. What is the difference between the highest and the lowest ODA received (in %) in 1960?
Your answer should be very brief. 4.83. What is the difference between the highest and the lowest ODA received (in %) of 1961?
Your response must be concise. 5.19. What is the difference between the highest and the lowest ODA received (in %) of 1962?
Offer a terse response. 8.75. What is the difference between the highest and the lowest ODA received (in %) in 1963?
Offer a terse response. 2.9. 